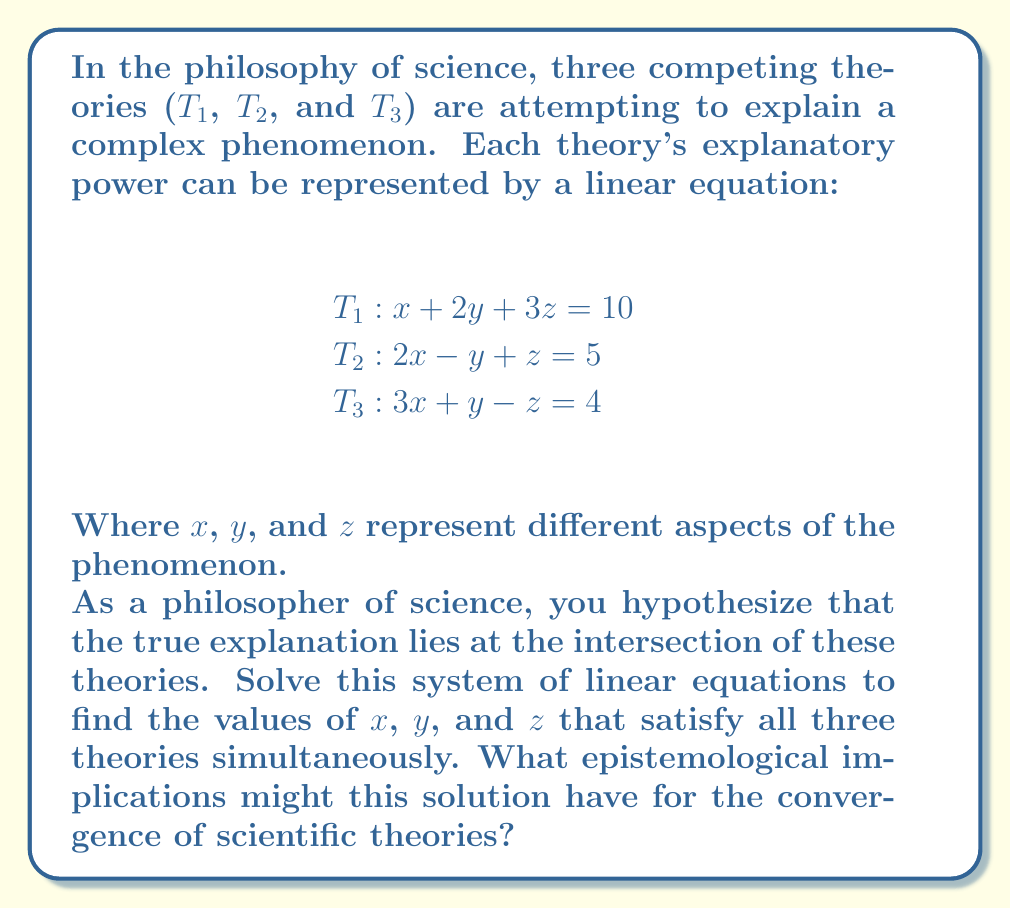Teach me how to tackle this problem. To solve this system of linear equations, we'll use the elimination method:

1) First, let's eliminate $z$ by adding equation T1 and T2:
   $(x + 2y + 3z) + (2x - y + z) = 10 + 5$
   $3x + y + 4z = 15$ ... (Eq. 4)

2) Now, let's eliminate $z$ by subtracting T3 from Eq. 4:
   $(3x + y + 4z) - (3x + y - z) = 15 - 4$
   $5z = 11$
   $z = \frac{11}{5} = 2.2$

3) Substitute $z = 2.2$ into T1 and T2:
   T1: $x + 2y + 3(2.2) = 10$
       $x + 2y = 3.4$ ... (Eq. 5)
   
   T2: $2x - y + 2.2 = 5$
       $2x - y = 2.8$ ... (Eq. 6)

4) Add Eq. 5 and Eq. 6:
   $(x + 2y) + (2x - y) = 3.4 + 2.8$
   $3x + y = 6.2$

5) Subtract Eq. 6 from this:
   $(3x + y) - (2x - y) = 6.2 - 2.8$
   $x + 2y = 3.4$
   $y = 1.7$

6) Substitute $y = 1.7$ into Eq. 5:
   $x + 2(1.7) = 3.4$
   $x = 3.4 - 3.4 = 0$

Therefore, the solution is $x = 0$, $y = 1.7$, and $z = 2.2$.

Epistemological implications:
1. Convergence: The solution demonstrates that seemingly conflicting theories can converge on a single explanation, suggesting that scientific progress often involves synthesizing multiple perspectives.

2. Complementarity: Each theory contributes uniquely to the final solution, implying that diverse approaches in science can be complementary rather than strictly competitive.

3. Reductionism vs. Holism: The solution requires considering all theories simultaneously, highlighting the importance of holistic approaches in understanding complex phenomena.

4. Limits of individual theories: No single theory fully explains the phenomenon, underscoring the limitations of individual scientific models and the need for integration.

5. Interdisciplinarity: The convergence of theories may represent the value of interdisciplinary approaches in science, where insights from different fields combine to provide a more complete understanding.
Answer: The solution to the system of linear equations is:
$x = 0$
$y = 1.7$
$z = 2.2$

This solution represents the point of convergence for the three scientific theories, suggesting that a comprehensive understanding of the phenomenon requires elements from all three perspectives. 